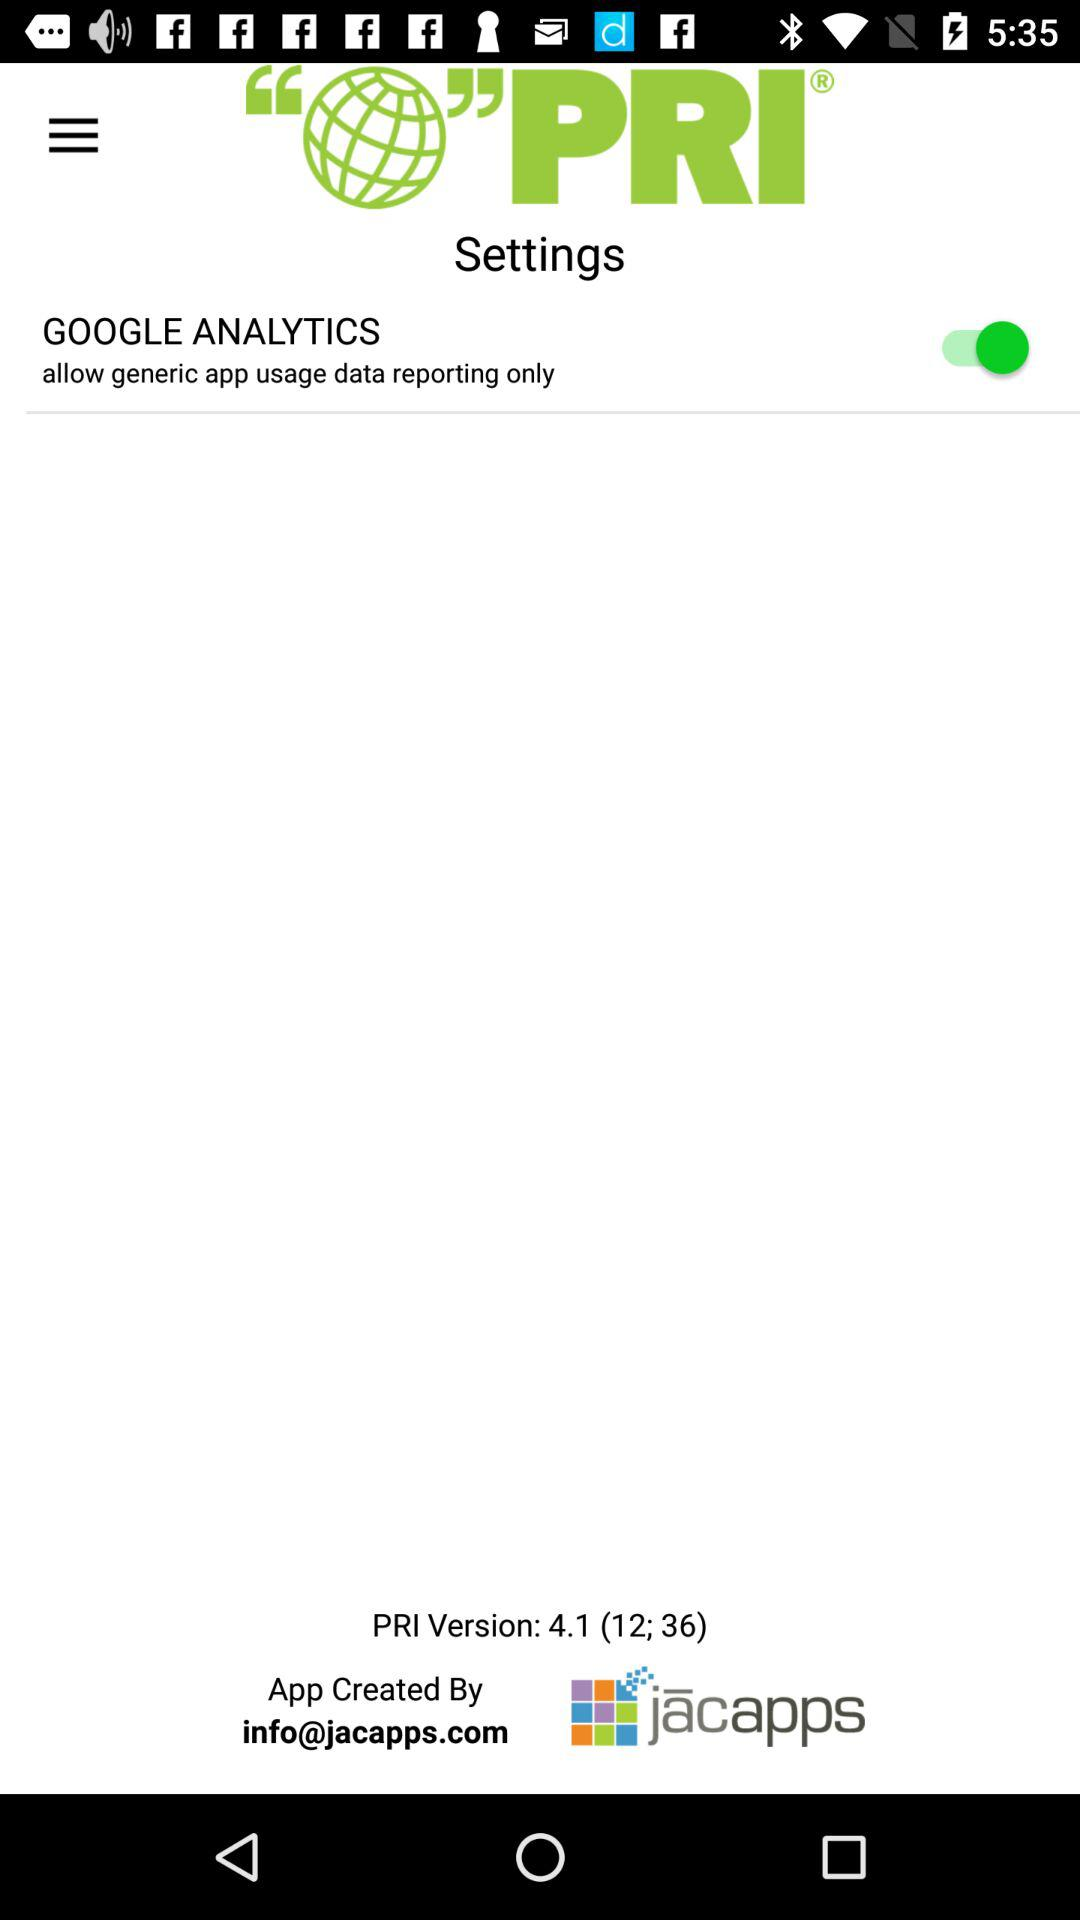What is the status of "GOOGLE ANALYTICS"? The status is "on". 